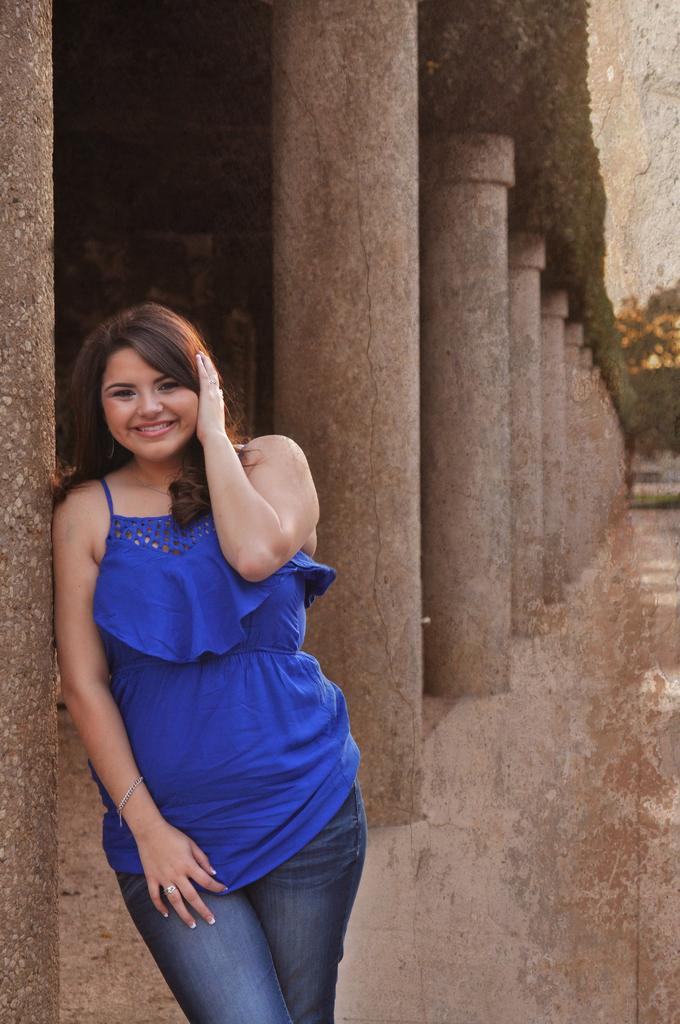Who is present in the image? There is a woman in the image. What is the woman wearing? The woman is wearing a blue dress. What expression does the woman have? The woman is smiling. What architectural features can be seen in the image? There are pillars in the image. What type of print can be seen on the woman's dress in the image? There is no print visible on the woman's dress in the image; it is a solid blue color. 